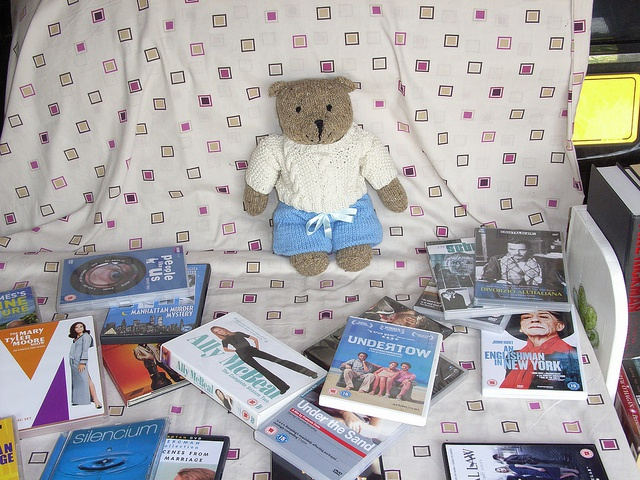Describe the objects in this image and their specific colors. I can see chair in lightgray, darkgray, black, and gray tones, teddy bear in black, lightgray, gray, and darkgray tones, book in black, darkgray, gray, and lavender tones, book in black, lightgray, darkgray, red, and purple tones, and book in black, lightgray, darkgray, and gray tones in this image. 